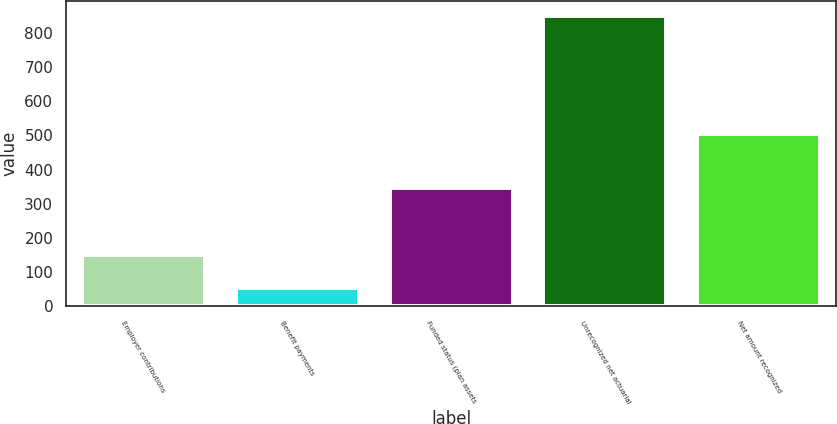Convert chart. <chart><loc_0><loc_0><loc_500><loc_500><bar_chart><fcel>Employer contributions<fcel>Benefit payments<fcel>Funded status (plan assets<fcel>Unrecognized net actuarial<fcel>Net amount recognized<nl><fcel>150<fcel>54<fcel>347<fcel>850<fcel>503<nl></chart> 